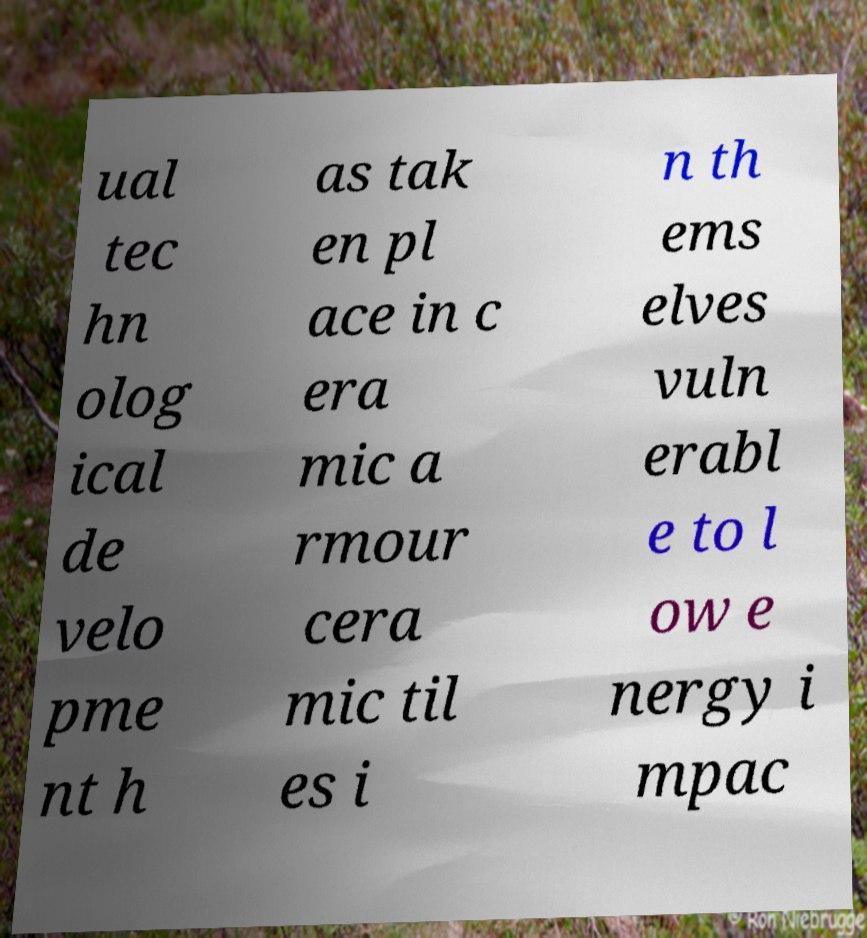Could you assist in decoding the text presented in this image and type it out clearly? ual tec hn olog ical de velo pme nt h as tak en pl ace in c era mic a rmour cera mic til es i n th ems elves vuln erabl e to l ow e nergy i mpac 